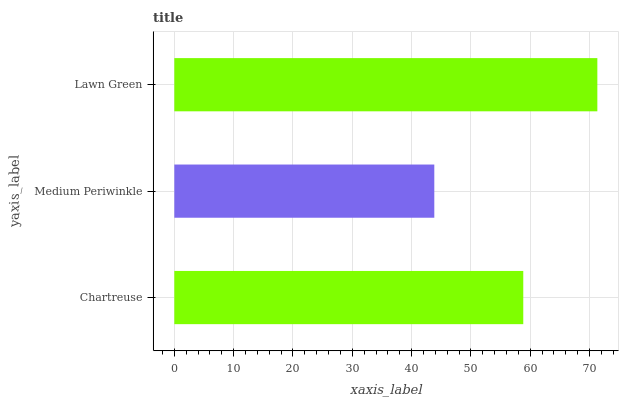Is Medium Periwinkle the minimum?
Answer yes or no. Yes. Is Lawn Green the maximum?
Answer yes or no. Yes. Is Lawn Green the minimum?
Answer yes or no. No. Is Medium Periwinkle the maximum?
Answer yes or no. No. Is Lawn Green greater than Medium Periwinkle?
Answer yes or no. Yes. Is Medium Periwinkle less than Lawn Green?
Answer yes or no. Yes. Is Medium Periwinkle greater than Lawn Green?
Answer yes or no. No. Is Lawn Green less than Medium Periwinkle?
Answer yes or no. No. Is Chartreuse the high median?
Answer yes or no. Yes. Is Chartreuse the low median?
Answer yes or no. Yes. Is Lawn Green the high median?
Answer yes or no. No. Is Medium Periwinkle the low median?
Answer yes or no. No. 